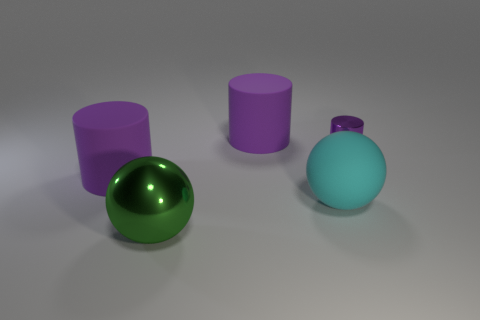What can you infer about the lighting and shadows in the scene? The lighting in the scene is diffused, creating soft shadows that extend opposite to the light source, which seems to be coming from the top right corner of the image. The shadows are cast primarily to the left and slightly behind the objects, suggesting that the light is not only above but also at a slight angle to them. 